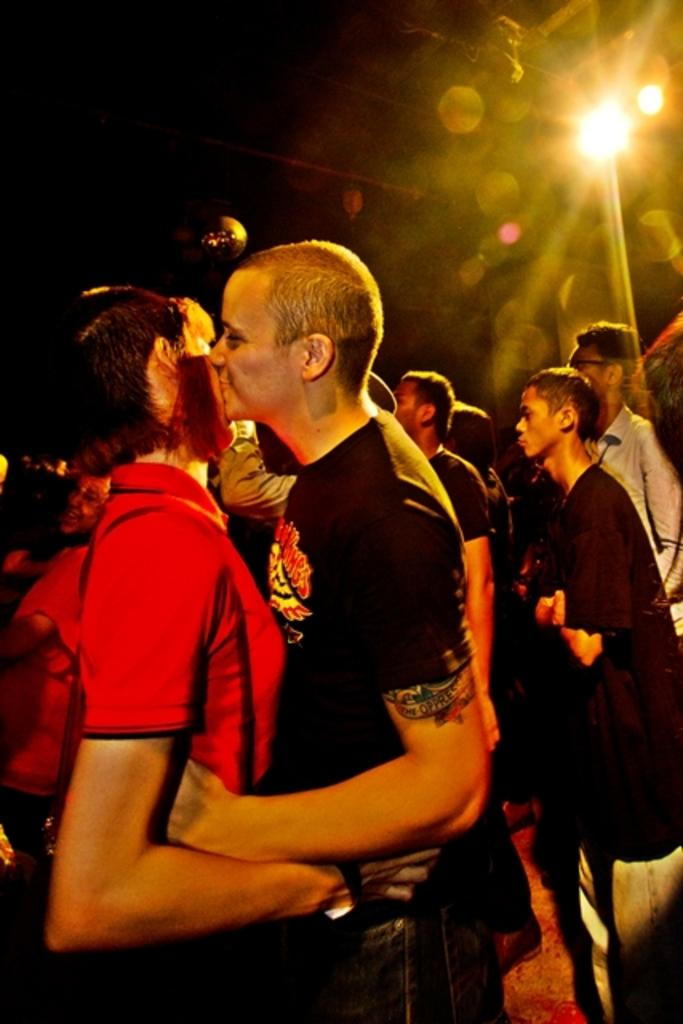Who is in the image with the man? The man is kissing a woman in the image. What is the man doing to the woman? The man is kissing the woman in the image. Can you describe the background of the image? There are other people and a light pole in the background of the image. What type of spade is the man using to make a statement in the image? There is no spade or statement being made in the image; the man is kissing a woman. 